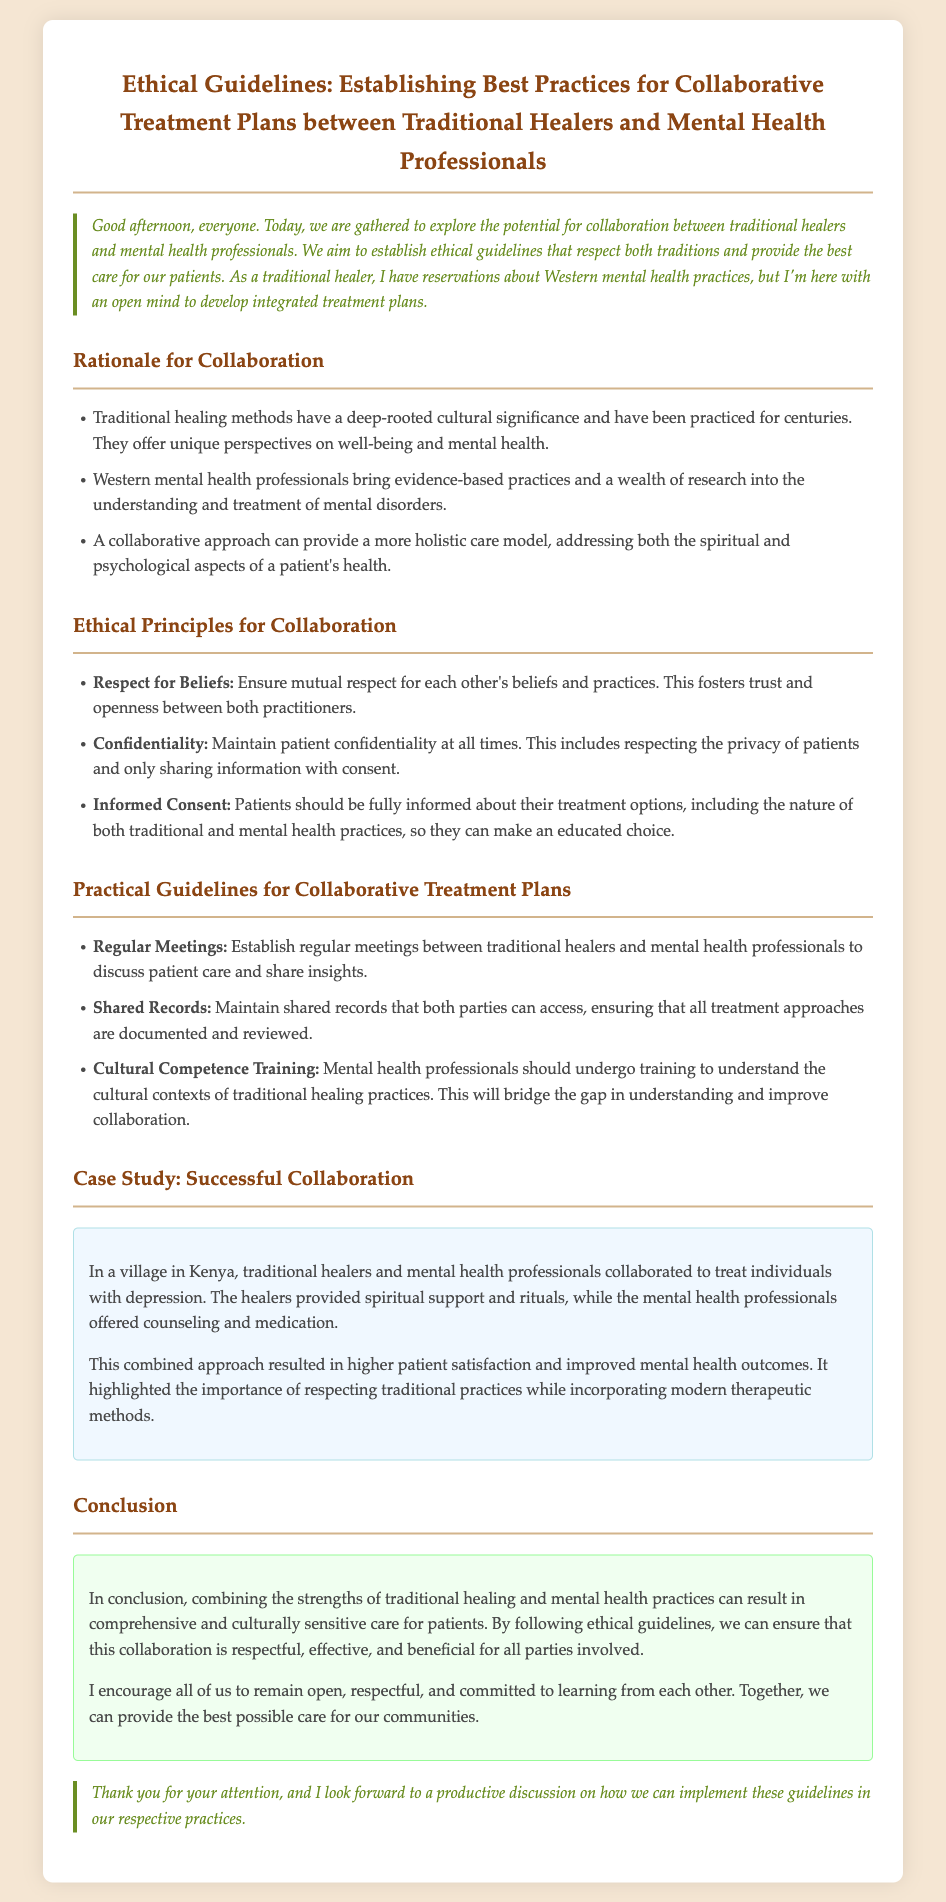What is the document's title? The title of the document is found in the heading at the top of the transcript.
Answer: Ethical Guidelines: Establishing Best Practices for Collaborative Treatment Plans between Traditional Healers and Mental Health Professionals What is one ethical principle for collaboration mentioned? Ethical principles are listed in a specific section of the document.
Answer: Respect for Beliefs What type of training is suggested for mental health professionals? The document outlines specific practical guidelines, including types of training.
Answer: Cultural Competence Training What is the case study location? The case study included in the document specifies where the collaboration took place.
Answer: Kenya What should patients be informed about according to the ethical guidelines? The ethical principle of Informed Consent is addressed in the document.
Answer: Treatment options How did the combined approach impact patient satisfaction? The case study highlights the outcomes of collaborative practices on patient satisfaction.
Answer: Higher patient satisfaction What aspect of health does a collaborative approach aim to address? The rationale for collaboration outlines the dimensions of health the collaboration considers.
Answer: Spiritual and psychological aspects How many main sections does the document include? The structure of the document divides its content into clear sections.
Answer: Five 